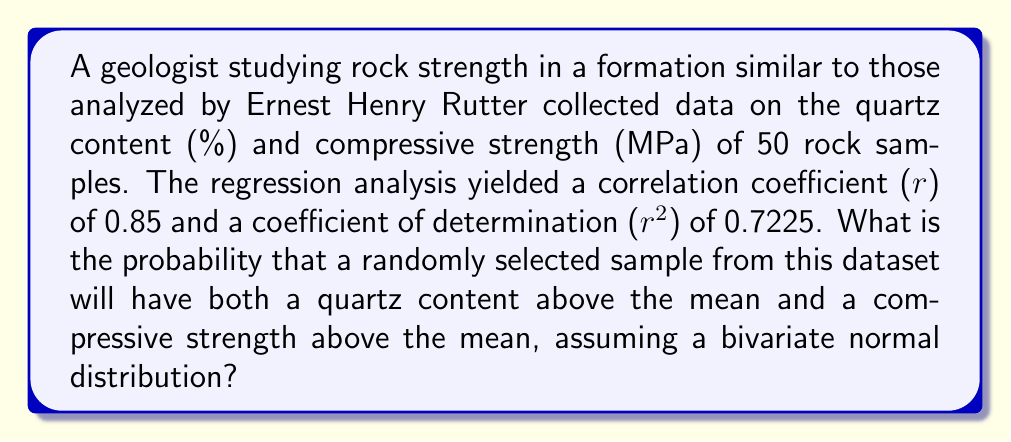Can you solve this math problem? To solve this problem, we'll follow these steps:

1) First, recall that for a bivariate normal distribution, the probability of both variables being above their respective means is related to the correlation coefficient (r).

2) The formula for this probability is:

   $$P(X > \mu_X, Y > \mu_Y) = \frac{1}{4} + \frac{1}{2\pi}\arcsin(r)$$

   Where $X$ and $Y$ are the two variables (quartz content and compressive strength in this case), $\mu_X$ and $\mu_Y$ are their respective means, and $r$ is the correlation coefficient.

3) We're given that $r = 0.85$. Let's substitute this into our formula:

   $$P(X > \mu_X, Y > \mu_Y) = \frac{1}{4} + \frac{1}{2\pi}\arcsin(0.85)$$

4) Now, let's calculate:
   
   $$\frac{1}{4} = 0.25$$
   $$\arcsin(0.85) \approx 1.0122$$
   $$\frac{1}{2\pi} \approx 0.1592$$

5) Putting it all together:

   $$P(X > \mu_X, Y > \mu_Y) = 0.25 + (0.1592 * 1.0122) \approx 0.4111$$

6) Therefore, the probability is approximately 0.4111 or about 41.11%.
Answer: 0.4111 